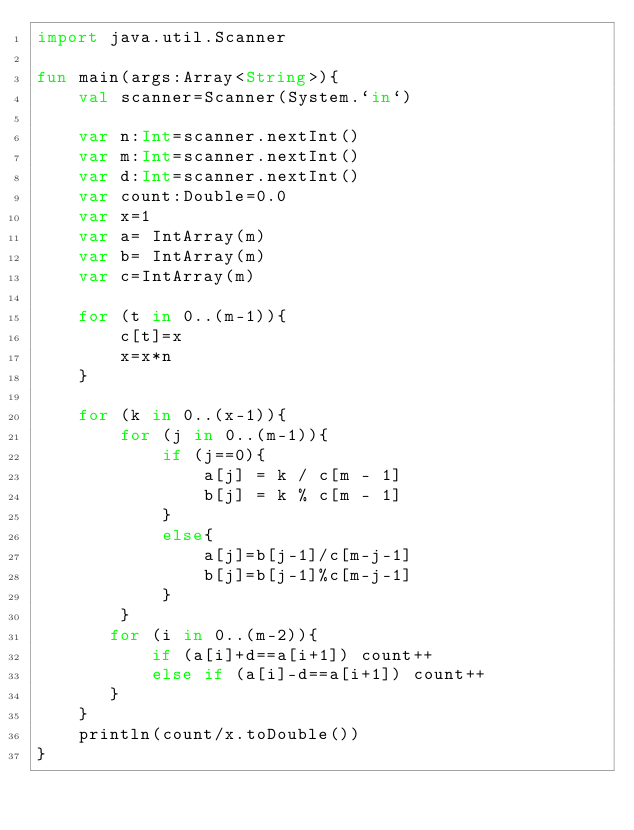Convert code to text. <code><loc_0><loc_0><loc_500><loc_500><_Kotlin_>import java.util.Scanner

fun main(args:Array<String>){
    val scanner=Scanner(System.`in`)

    var n:Int=scanner.nextInt()
    var m:Int=scanner.nextInt()
    var d:Int=scanner.nextInt()
    var count:Double=0.0
    var x=1
    var a= IntArray(m)
    var b= IntArray(m)
    var c=IntArray(m)

    for (t in 0..(m-1)){
        c[t]=x
        x=x*n
    }

    for (k in 0..(x-1)){
        for (j in 0..(m-1)){
            if (j==0){
                a[j] = k / c[m - 1]
                b[j] = k % c[m - 1]
            }
            else{
                a[j]=b[j-1]/c[m-j-1]
                b[j]=b[j-1]%c[m-j-1]
            }
        }
       for (i in 0..(m-2)){
           if (a[i]+d==a[i+1]) count++
           else if (a[i]-d==a[i+1]) count++
       }
    }
    println(count/x.toDouble())
}</code> 